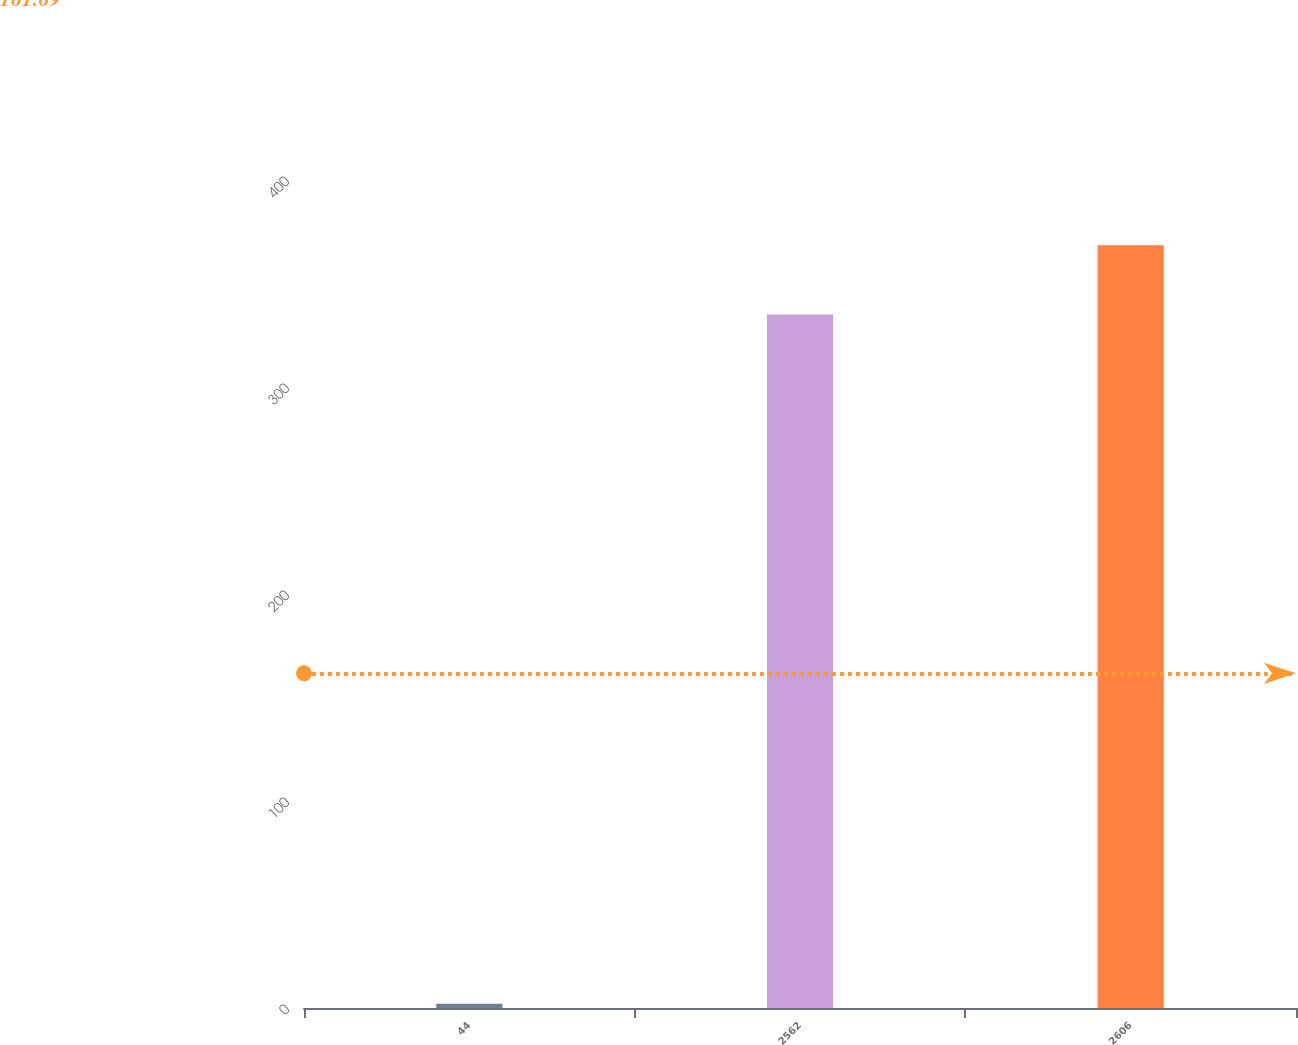<chart> <loc_0><loc_0><loc_500><loc_500><bar_chart><fcel>44<fcel>2562<fcel>2606<nl><fcel>2<fcel>335<fcel>368.5<nl></chart> 